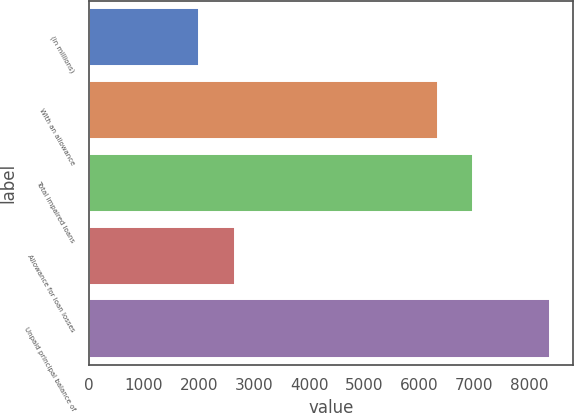<chart> <loc_0><loc_0><loc_500><loc_500><bar_chart><fcel>(in millions)<fcel>With an allowance<fcel>Total impaired loans<fcel>Allowance for loan losses<fcel>Unpaid principal balance of<nl><fcel>2009<fcel>6347<fcel>6983.4<fcel>2645.4<fcel>8373<nl></chart> 